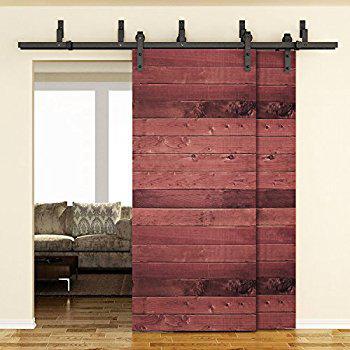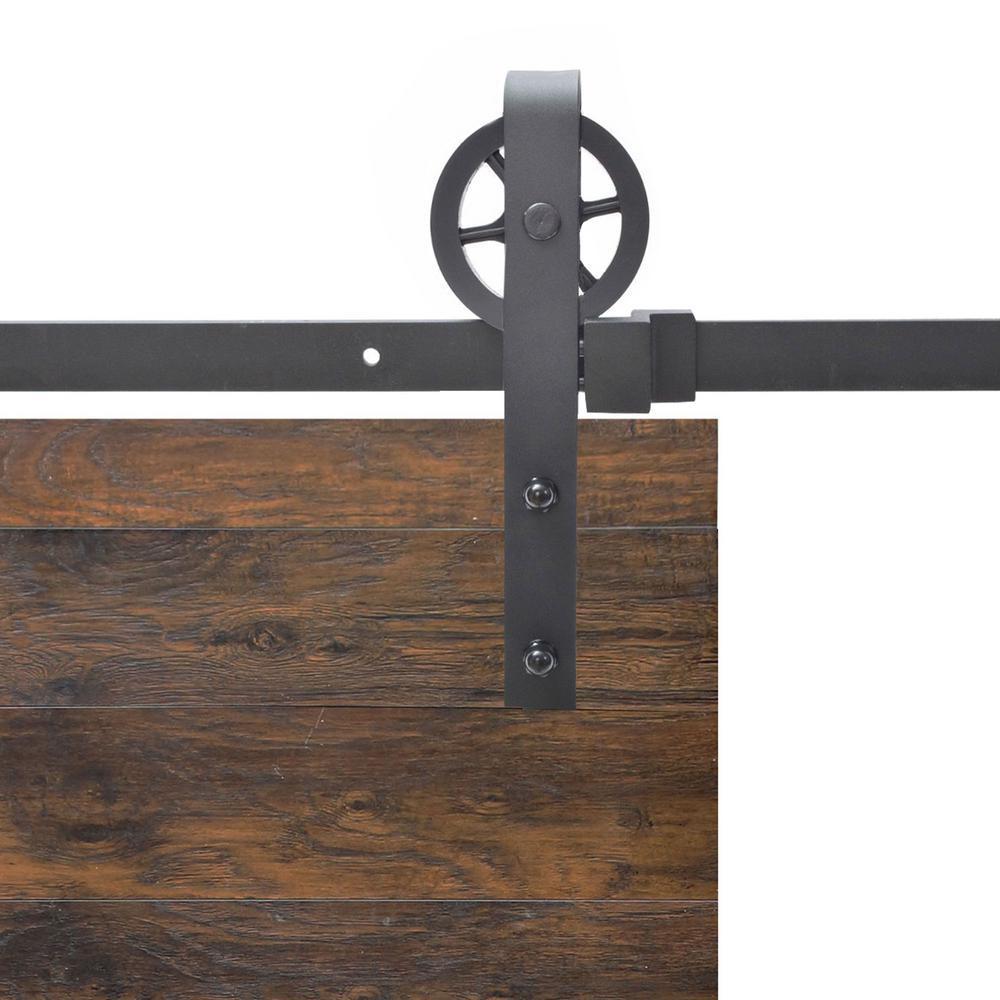The first image is the image on the left, the second image is the image on the right. For the images shown, is this caption "A door is mirrored." true? Answer yes or no. No. 